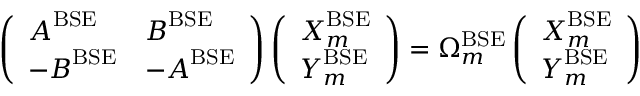<formula> <loc_0><loc_0><loc_500><loc_500>\left ( \begin{array} { l l } { A ^ { B S E } } & { B ^ { B S E } } \\ { - B ^ { B S E } } & { - A ^ { B S E } } \end{array} \right ) \left ( \begin{array} { l } { X _ { m } ^ { B S E } } \\ { Y _ { m } ^ { B S E } } \end{array} \right ) = \Omega _ { m } ^ { B S E } \left ( \begin{array} { l } { X _ { m } ^ { B S E } } \\ { Y _ { m } ^ { B S E } } \end{array} \right )</formula> 